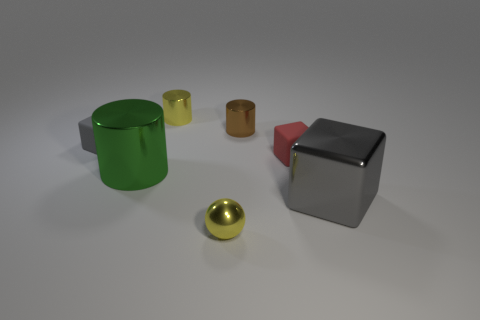Add 3 large gray things. How many objects exist? 10 Subtract all balls. How many objects are left? 6 Add 6 large gray shiny things. How many large gray shiny things exist? 7 Subtract 1 yellow spheres. How many objects are left? 6 Subtract all small yellow metallic cylinders. Subtract all small cyan metallic cylinders. How many objects are left? 6 Add 2 tiny yellow metallic spheres. How many tiny yellow metallic spheres are left? 3 